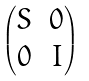<formula> <loc_0><loc_0><loc_500><loc_500>\begin{pmatrix} S & 0 \\ 0 & I \end{pmatrix}</formula> 